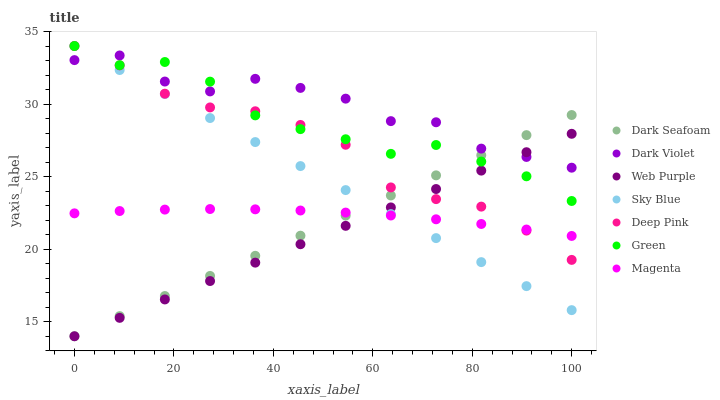Does Web Purple have the minimum area under the curve?
Answer yes or no. Yes. Does Dark Violet have the maximum area under the curve?
Answer yes or no. Yes. Does Dark Violet have the minimum area under the curve?
Answer yes or no. No. Does Web Purple have the maximum area under the curve?
Answer yes or no. No. Is Dark Seafoam the smoothest?
Answer yes or no. Yes. Is Dark Violet the roughest?
Answer yes or no. Yes. Is Web Purple the smoothest?
Answer yes or no. No. Is Web Purple the roughest?
Answer yes or no. No. Does Web Purple have the lowest value?
Answer yes or no. Yes. Does Dark Violet have the lowest value?
Answer yes or no. No. Does Sky Blue have the highest value?
Answer yes or no. Yes. Does Web Purple have the highest value?
Answer yes or no. No. Is Magenta less than Green?
Answer yes or no. Yes. Is Green greater than Magenta?
Answer yes or no. Yes. Does Sky Blue intersect Dark Seafoam?
Answer yes or no. Yes. Is Sky Blue less than Dark Seafoam?
Answer yes or no. No. Is Sky Blue greater than Dark Seafoam?
Answer yes or no. No. Does Magenta intersect Green?
Answer yes or no. No. 